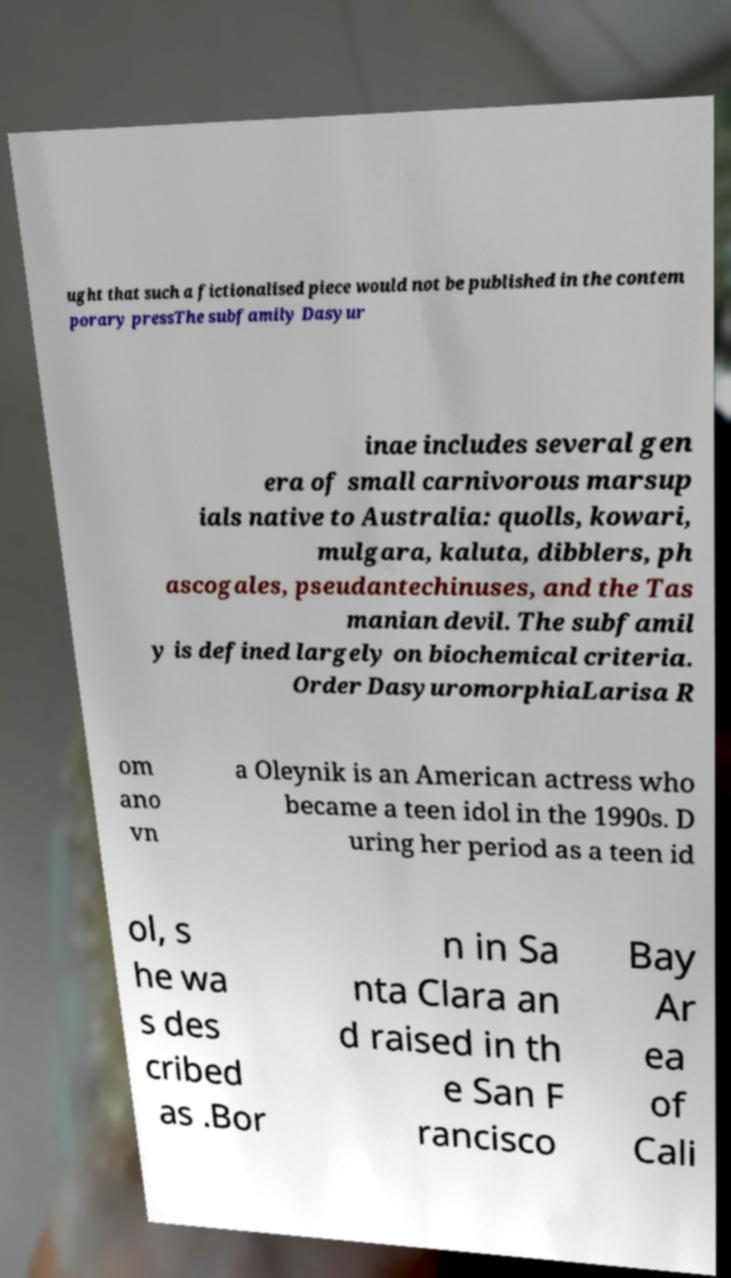Please read and relay the text visible in this image. What does it say? ught that such a fictionalised piece would not be published in the contem porary pressThe subfamily Dasyur inae includes several gen era of small carnivorous marsup ials native to Australia: quolls, kowari, mulgara, kaluta, dibblers, ph ascogales, pseudantechinuses, and the Tas manian devil. The subfamil y is defined largely on biochemical criteria. Order DasyuromorphiaLarisa R om ano vn a Oleynik is an American actress who became a teen idol in the 1990s. D uring her period as a teen id ol, s he wa s des cribed as .Bor n in Sa nta Clara an d raised in th e San F rancisco Bay Ar ea of Cali 